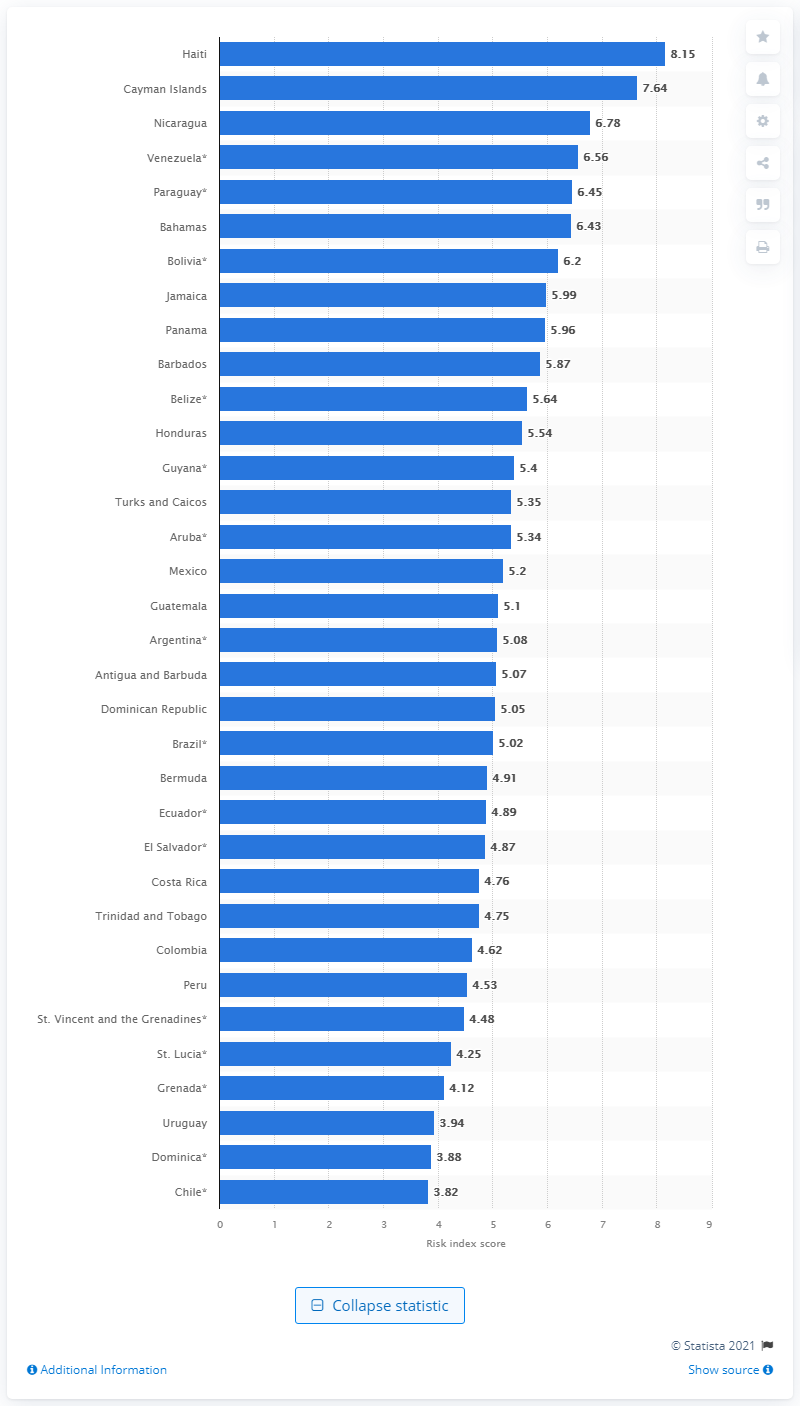Highlight a few significant elements in this photo. Haiti's index score in 2020 was 8.15. 